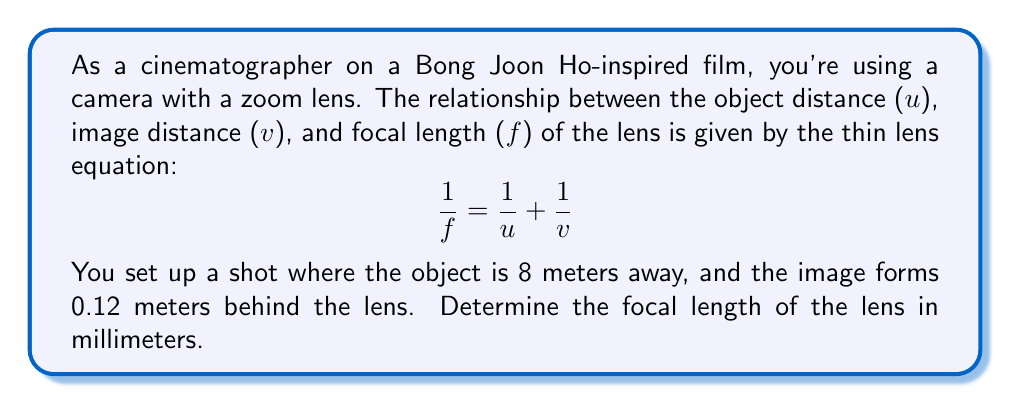Show me your answer to this math problem. Let's approach this step-by-step:

1) We start with the thin lens equation:

   $$\frac{1}{f} = \frac{1}{u} + \frac{1}{v}$$

2) We know that:
   - Object distance, $u = 8$ meters
   - Image distance, $v = 0.12$ meters

3) Let's substitute these values into the equation:

   $$\frac{1}{f} = \frac{1}{8} + \frac{1}{0.12}$$

4) Now, let's solve for $f$:

   $$\frac{1}{f} = 0.125 + 8.3333$$
   $$\frac{1}{f} = 8.4583$$

5) To find $f$, we take the reciprocal of both sides:

   $$f = \frac{1}{8.4583}$$

6) Calculating this:

   $$f \approx 0.1182 \text{ meters}$$

7) Convert to millimeters:

   $$f \approx 0.1182 \times 1000 = 118.2 \text{ mm}$$

Therefore, the focal length of the lens is approximately 118.2 mm.
Answer: 118.2 mm 